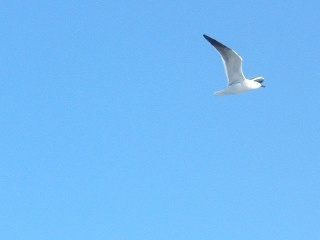Describe the objects in this image and their specific colors. I can see a bird in lightblue, darkgray, and white tones in this image. 